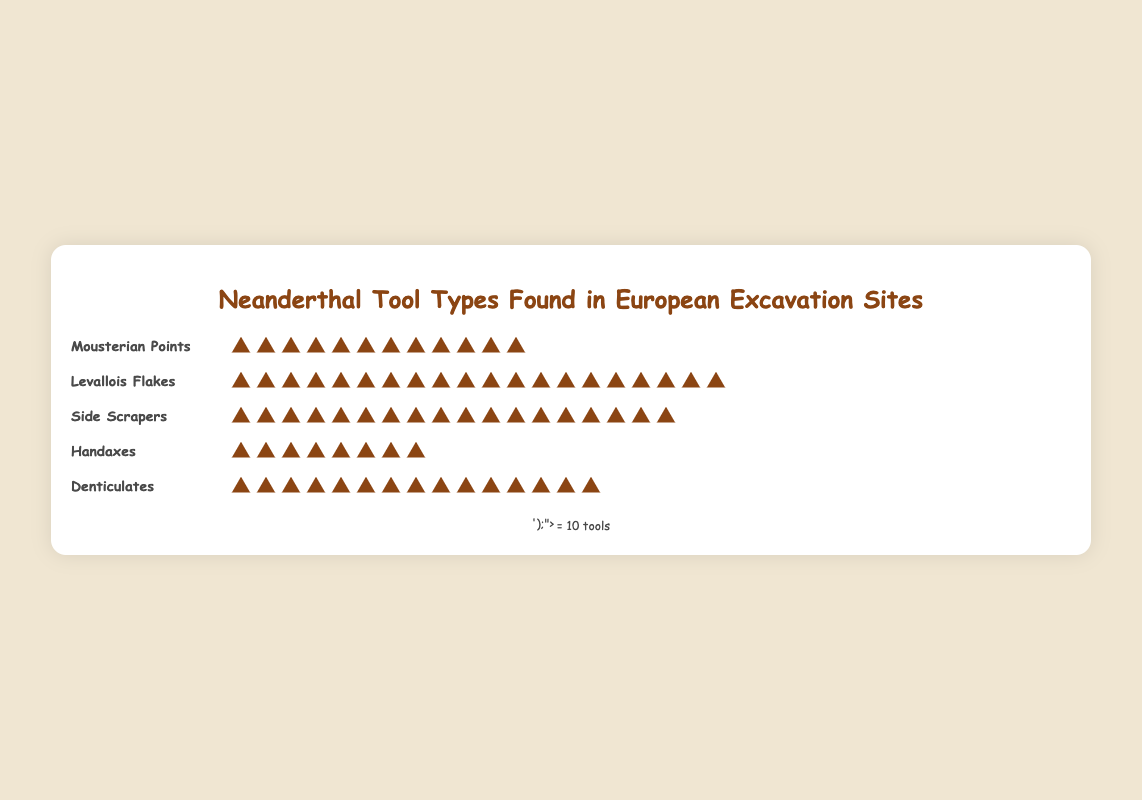How many tool types are represented in the figure? There are 5 different tool names listed in the figure: Mousterian Points, Levallois Flakes, Side Scrapers, Handaxes, and Denticulates.
Answer: 5 Which tool type has the highest occurrence? The Levallois Flakes row has the most tool icons, representing 200 tools.
Answer: Levallois Flakes How many more Levallois Flakes are there compared to Handaxes? Levallois Flakes have 200 tools and Handaxes have 80 tools. The difference is 200 - 80 = 120.
Answer: 120 What is the combined total of Mousterian Points and Denticulates found in the sites? Mousterian Points have 120 tools and Denticulates have 150 tools. The combined total is 120 + 150 = 270.
Answer: 270 Which tool type has the lowest occurrence? The Handaxes row has the fewest tool icons, representing 80 tools.
Answer: Handaxes How many tools in total are represented in the figure? Summing the tool counts: Mousterian Points (120) + Levallois Flakes (200) + Side Scrapers (180) + Handaxes (80) + Denticulates (150). Total = 120 + 200 + 180 + 80 + 150 = 730.
Answer: 730 Are there more Side Scrapers or Denticulates? Side Scrapers have 180 tools, while Denticulates have 150 tools. 180 > 150, so Side Scrapers are more.
Answer: Side Scrapers What is the average number of tools per type across the different tool types? Summing the counts for all tool types: 120 (Mousterian Points) + 200 (Levallois Flakes) + 180 (Side Scrapers) + 80 (Handaxes) + 150 (Denticulates) = 730. There are 5 tool types, so average = 730 / 5 = 146.
Answer: 146 Which tool types have more than 100 occurrences? Mousterian Points (120), Levallois Flakes (200), Side Scrapers (180), and Denticulates (150) each have more than 100 tools.
Answer: Mousterian Points, Levallois Flakes, Side Scrapers, Denticulates 